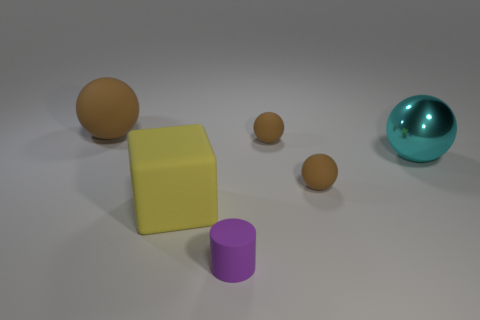How many other objects are there of the same shape as the big shiny thing?
Make the answer very short. 3. What number of matte things are either small brown blocks or large yellow things?
Make the answer very short. 1. The large sphere on the right side of the brown matte ball on the left side of the purple cylinder is made of what material?
Your answer should be compact. Metal. Is the number of large things to the right of the purple thing greater than the number of tiny purple rubber blocks?
Offer a terse response. Yes. Is there a yellow cube that has the same material as the purple object?
Provide a succinct answer. Yes. Is the shape of the small thing that is behind the big shiny ball the same as  the big yellow object?
Your answer should be very brief. No. There is a sphere that is to the left of the big thing in front of the big cyan sphere; how many large spheres are on the right side of it?
Make the answer very short. 1. Is the number of cyan shiny things in front of the small cylinder less than the number of tiny rubber cylinders that are on the right side of the big cyan ball?
Your response must be concise. No. What color is the other big object that is the same shape as the large brown thing?
Provide a succinct answer. Cyan. What is the size of the yellow matte block?
Your answer should be very brief. Large. 